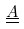Convert formula to latex. <formula><loc_0><loc_0><loc_500><loc_500>\underline { \underline { A } }</formula> 